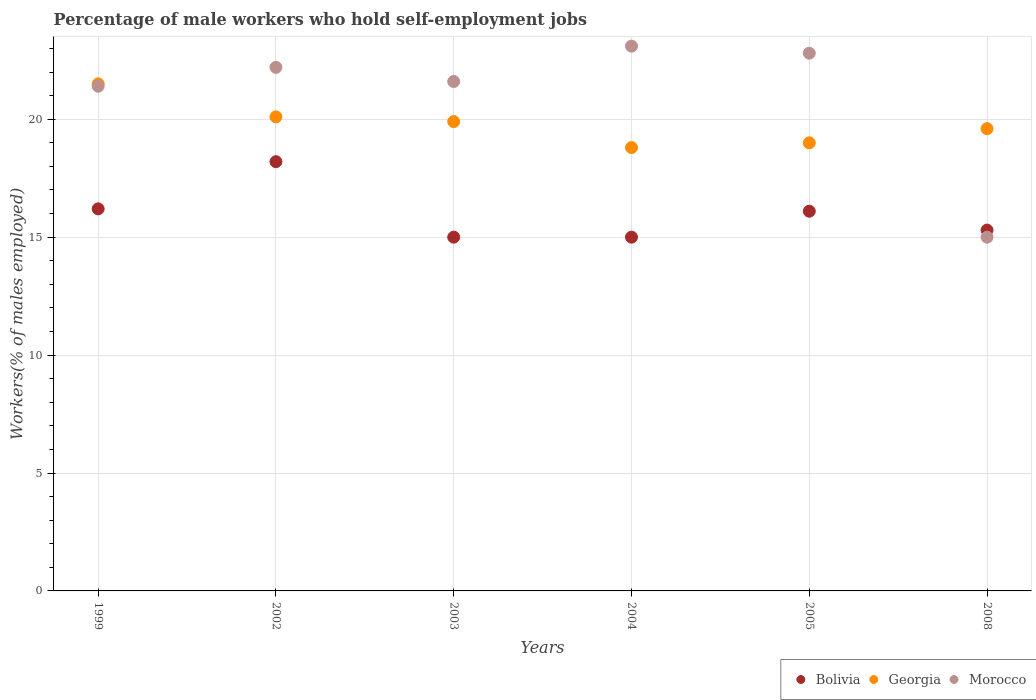What is the percentage of self-employed male workers in Bolivia in 2008?
Provide a succinct answer. 15.3. Across all years, what is the maximum percentage of self-employed male workers in Bolivia?
Your answer should be very brief. 18.2. Across all years, what is the minimum percentage of self-employed male workers in Georgia?
Your response must be concise. 18.8. In which year was the percentage of self-employed male workers in Bolivia maximum?
Your response must be concise. 2002. What is the total percentage of self-employed male workers in Bolivia in the graph?
Make the answer very short. 95.8. What is the difference between the percentage of self-employed male workers in Morocco in 2002 and that in 2003?
Your response must be concise. 0.6. What is the difference between the percentage of self-employed male workers in Georgia in 2004 and the percentage of self-employed male workers in Morocco in 2002?
Provide a succinct answer. -3.4. What is the average percentage of self-employed male workers in Bolivia per year?
Your answer should be compact. 15.97. In the year 2002, what is the difference between the percentage of self-employed male workers in Bolivia and percentage of self-employed male workers in Georgia?
Your answer should be very brief. -1.9. What is the ratio of the percentage of self-employed male workers in Bolivia in 2002 to that in 2008?
Ensure brevity in your answer.  1.19. Is the percentage of self-employed male workers in Morocco in 2002 less than that in 2005?
Ensure brevity in your answer.  Yes. Is the difference between the percentage of self-employed male workers in Bolivia in 2002 and 2008 greater than the difference between the percentage of self-employed male workers in Georgia in 2002 and 2008?
Offer a terse response. Yes. What is the difference between the highest and the lowest percentage of self-employed male workers in Morocco?
Offer a very short reply. 8.1. Is the sum of the percentage of self-employed male workers in Georgia in 1999 and 2002 greater than the maximum percentage of self-employed male workers in Bolivia across all years?
Your response must be concise. Yes. Is the percentage of self-employed male workers in Morocco strictly greater than the percentage of self-employed male workers in Bolivia over the years?
Offer a very short reply. No. How many dotlines are there?
Offer a very short reply. 3. What is the difference between two consecutive major ticks on the Y-axis?
Keep it short and to the point. 5. Does the graph contain any zero values?
Your response must be concise. No. How are the legend labels stacked?
Your answer should be very brief. Horizontal. What is the title of the graph?
Give a very brief answer. Percentage of male workers who hold self-employment jobs. Does "Georgia" appear as one of the legend labels in the graph?
Ensure brevity in your answer.  Yes. What is the label or title of the Y-axis?
Provide a short and direct response. Workers(% of males employed). What is the Workers(% of males employed) of Bolivia in 1999?
Provide a short and direct response. 16.2. What is the Workers(% of males employed) of Morocco in 1999?
Offer a very short reply. 21.4. What is the Workers(% of males employed) of Bolivia in 2002?
Offer a terse response. 18.2. What is the Workers(% of males employed) of Georgia in 2002?
Offer a terse response. 20.1. What is the Workers(% of males employed) in Morocco in 2002?
Give a very brief answer. 22.2. What is the Workers(% of males employed) of Bolivia in 2003?
Provide a short and direct response. 15. What is the Workers(% of males employed) in Georgia in 2003?
Make the answer very short. 19.9. What is the Workers(% of males employed) in Morocco in 2003?
Provide a succinct answer. 21.6. What is the Workers(% of males employed) of Bolivia in 2004?
Keep it short and to the point. 15. What is the Workers(% of males employed) of Georgia in 2004?
Your answer should be compact. 18.8. What is the Workers(% of males employed) in Morocco in 2004?
Give a very brief answer. 23.1. What is the Workers(% of males employed) of Bolivia in 2005?
Offer a terse response. 16.1. What is the Workers(% of males employed) of Georgia in 2005?
Your response must be concise. 19. What is the Workers(% of males employed) of Morocco in 2005?
Give a very brief answer. 22.8. What is the Workers(% of males employed) in Bolivia in 2008?
Your response must be concise. 15.3. What is the Workers(% of males employed) in Georgia in 2008?
Your answer should be compact. 19.6. What is the Workers(% of males employed) of Morocco in 2008?
Your answer should be compact. 15. Across all years, what is the maximum Workers(% of males employed) of Bolivia?
Provide a succinct answer. 18.2. Across all years, what is the maximum Workers(% of males employed) of Morocco?
Make the answer very short. 23.1. Across all years, what is the minimum Workers(% of males employed) of Georgia?
Your answer should be compact. 18.8. Across all years, what is the minimum Workers(% of males employed) in Morocco?
Offer a very short reply. 15. What is the total Workers(% of males employed) in Bolivia in the graph?
Give a very brief answer. 95.8. What is the total Workers(% of males employed) in Georgia in the graph?
Your answer should be compact. 118.9. What is the total Workers(% of males employed) of Morocco in the graph?
Your answer should be compact. 126.1. What is the difference between the Workers(% of males employed) of Georgia in 1999 and that in 2002?
Offer a very short reply. 1.4. What is the difference between the Workers(% of males employed) in Bolivia in 1999 and that in 2003?
Your answer should be compact. 1.2. What is the difference between the Workers(% of males employed) in Bolivia in 1999 and that in 2005?
Give a very brief answer. 0.1. What is the difference between the Workers(% of males employed) in Morocco in 1999 and that in 2005?
Your answer should be compact. -1.4. What is the difference between the Workers(% of males employed) in Bolivia in 1999 and that in 2008?
Give a very brief answer. 0.9. What is the difference between the Workers(% of males employed) of Morocco in 1999 and that in 2008?
Give a very brief answer. 6.4. What is the difference between the Workers(% of males employed) in Georgia in 2002 and that in 2004?
Your answer should be compact. 1.3. What is the difference between the Workers(% of males employed) in Morocco in 2002 and that in 2004?
Your answer should be compact. -0.9. What is the difference between the Workers(% of males employed) of Bolivia in 2002 and that in 2005?
Offer a terse response. 2.1. What is the difference between the Workers(% of males employed) of Georgia in 2002 and that in 2005?
Provide a short and direct response. 1.1. What is the difference between the Workers(% of males employed) in Georgia in 2002 and that in 2008?
Provide a succinct answer. 0.5. What is the difference between the Workers(% of males employed) in Bolivia in 2003 and that in 2004?
Offer a very short reply. 0. What is the difference between the Workers(% of males employed) of Georgia in 2003 and that in 2004?
Ensure brevity in your answer.  1.1. What is the difference between the Workers(% of males employed) of Morocco in 2003 and that in 2004?
Your answer should be compact. -1.5. What is the difference between the Workers(% of males employed) of Bolivia in 2003 and that in 2005?
Provide a succinct answer. -1.1. What is the difference between the Workers(% of males employed) in Georgia in 2003 and that in 2005?
Keep it short and to the point. 0.9. What is the difference between the Workers(% of males employed) in Morocco in 2003 and that in 2005?
Provide a succinct answer. -1.2. What is the difference between the Workers(% of males employed) in Bolivia in 2003 and that in 2008?
Your response must be concise. -0.3. What is the difference between the Workers(% of males employed) of Morocco in 2003 and that in 2008?
Offer a very short reply. 6.6. What is the difference between the Workers(% of males employed) of Bolivia in 2004 and that in 2005?
Make the answer very short. -1.1. What is the difference between the Workers(% of males employed) in Morocco in 2004 and that in 2005?
Offer a very short reply. 0.3. What is the difference between the Workers(% of males employed) in Georgia in 2004 and that in 2008?
Your answer should be very brief. -0.8. What is the difference between the Workers(% of males employed) in Bolivia in 1999 and the Workers(% of males employed) in Georgia in 2004?
Make the answer very short. -2.6. What is the difference between the Workers(% of males employed) in Georgia in 1999 and the Workers(% of males employed) in Morocco in 2004?
Keep it short and to the point. -1.6. What is the difference between the Workers(% of males employed) of Bolivia in 1999 and the Workers(% of males employed) of Georgia in 2005?
Offer a very short reply. -2.8. What is the difference between the Workers(% of males employed) in Bolivia in 1999 and the Workers(% of males employed) in Morocco in 2005?
Make the answer very short. -6.6. What is the difference between the Workers(% of males employed) of Georgia in 1999 and the Workers(% of males employed) of Morocco in 2005?
Provide a succinct answer. -1.3. What is the difference between the Workers(% of males employed) in Bolivia in 1999 and the Workers(% of males employed) in Georgia in 2008?
Your answer should be compact. -3.4. What is the difference between the Workers(% of males employed) in Bolivia in 1999 and the Workers(% of males employed) in Morocco in 2008?
Offer a very short reply. 1.2. What is the difference between the Workers(% of males employed) in Georgia in 1999 and the Workers(% of males employed) in Morocco in 2008?
Your answer should be compact. 6.5. What is the difference between the Workers(% of males employed) in Georgia in 2002 and the Workers(% of males employed) in Morocco in 2003?
Keep it short and to the point. -1.5. What is the difference between the Workers(% of males employed) in Bolivia in 2002 and the Workers(% of males employed) in Morocco in 2004?
Offer a very short reply. -4.9. What is the difference between the Workers(% of males employed) in Georgia in 2002 and the Workers(% of males employed) in Morocco in 2004?
Ensure brevity in your answer.  -3. What is the difference between the Workers(% of males employed) of Bolivia in 2002 and the Workers(% of males employed) of Georgia in 2005?
Offer a terse response. -0.8. What is the difference between the Workers(% of males employed) of Bolivia in 2002 and the Workers(% of males employed) of Morocco in 2005?
Keep it short and to the point. -4.6. What is the difference between the Workers(% of males employed) of Georgia in 2002 and the Workers(% of males employed) of Morocco in 2005?
Your response must be concise. -2.7. What is the difference between the Workers(% of males employed) in Bolivia in 2003 and the Workers(% of males employed) in Morocco in 2004?
Your answer should be compact. -8.1. What is the difference between the Workers(% of males employed) of Bolivia in 2003 and the Workers(% of males employed) of Georgia in 2005?
Provide a succinct answer. -4. What is the difference between the Workers(% of males employed) of Bolivia in 2003 and the Workers(% of males employed) of Georgia in 2008?
Ensure brevity in your answer.  -4.6. What is the difference between the Workers(% of males employed) of Bolivia in 2003 and the Workers(% of males employed) of Morocco in 2008?
Provide a succinct answer. 0. What is the difference between the Workers(% of males employed) in Bolivia in 2004 and the Workers(% of males employed) in Georgia in 2005?
Your answer should be very brief. -4. What is the difference between the Workers(% of males employed) of Bolivia in 2004 and the Workers(% of males employed) of Morocco in 2005?
Provide a succinct answer. -7.8. What is the difference between the Workers(% of males employed) in Bolivia in 2004 and the Workers(% of males employed) in Georgia in 2008?
Offer a very short reply. -4.6. What is the difference between the Workers(% of males employed) of Georgia in 2004 and the Workers(% of males employed) of Morocco in 2008?
Ensure brevity in your answer.  3.8. What is the difference between the Workers(% of males employed) of Georgia in 2005 and the Workers(% of males employed) of Morocco in 2008?
Give a very brief answer. 4. What is the average Workers(% of males employed) in Bolivia per year?
Ensure brevity in your answer.  15.97. What is the average Workers(% of males employed) in Georgia per year?
Give a very brief answer. 19.82. What is the average Workers(% of males employed) in Morocco per year?
Your answer should be very brief. 21.02. In the year 1999, what is the difference between the Workers(% of males employed) of Bolivia and Workers(% of males employed) of Georgia?
Offer a very short reply. -5.3. In the year 1999, what is the difference between the Workers(% of males employed) of Bolivia and Workers(% of males employed) of Morocco?
Ensure brevity in your answer.  -5.2. In the year 2003, what is the difference between the Workers(% of males employed) in Bolivia and Workers(% of males employed) in Morocco?
Offer a terse response. -6.6. In the year 2004, what is the difference between the Workers(% of males employed) of Bolivia and Workers(% of males employed) of Georgia?
Ensure brevity in your answer.  -3.8. In the year 2004, what is the difference between the Workers(% of males employed) of Bolivia and Workers(% of males employed) of Morocco?
Your answer should be compact. -8.1. In the year 2005, what is the difference between the Workers(% of males employed) in Bolivia and Workers(% of males employed) in Georgia?
Provide a short and direct response. -2.9. In the year 2005, what is the difference between the Workers(% of males employed) in Bolivia and Workers(% of males employed) in Morocco?
Your response must be concise. -6.7. In the year 2005, what is the difference between the Workers(% of males employed) in Georgia and Workers(% of males employed) in Morocco?
Offer a terse response. -3.8. In the year 2008, what is the difference between the Workers(% of males employed) in Georgia and Workers(% of males employed) in Morocco?
Give a very brief answer. 4.6. What is the ratio of the Workers(% of males employed) of Bolivia in 1999 to that in 2002?
Ensure brevity in your answer.  0.89. What is the ratio of the Workers(% of males employed) of Georgia in 1999 to that in 2002?
Provide a succinct answer. 1.07. What is the ratio of the Workers(% of males employed) of Bolivia in 1999 to that in 2003?
Provide a succinct answer. 1.08. What is the ratio of the Workers(% of males employed) of Georgia in 1999 to that in 2003?
Give a very brief answer. 1.08. What is the ratio of the Workers(% of males employed) of Morocco in 1999 to that in 2003?
Your answer should be very brief. 0.99. What is the ratio of the Workers(% of males employed) of Georgia in 1999 to that in 2004?
Your answer should be compact. 1.14. What is the ratio of the Workers(% of males employed) of Morocco in 1999 to that in 2004?
Give a very brief answer. 0.93. What is the ratio of the Workers(% of males employed) in Georgia in 1999 to that in 2005?
Your response must be concise. 1.13. What is the ratio of the Workers(% of males employed) of Morocco in 1999 to that in 2005?
Your response must be concise. 0.94. What is the ratio of the Workers(% of males employed) in Bolivia in 1999 to that in 2008?
Offer a terse response. 1.06. What is the ratio of the Workers(% of males employed) of Georgia in 1999 to that in 2008?
Your answer should be compact. 1.1. What is the ratio of the Workers(% of males employed) of Morocco in 1999 to that in 2008?
Your response must be concise. 1.43. What is the ratio of the Workers(% of males employed) in Bolivia in 2002 to that in 2003?
Offer a terse response. 1.21. What is the ratio of the Workers(% of males employed) in Georgia in 2002 to that in 2003?
Ensure brevity in your answer.  1.01. What is the ratio of the Workers(% of males employed) in Morocco in 2002 to that in 2003?
Ensure brevity in your answer.  1.03. What is the ratio of the Workers(% of males employed) of Bolivia in 2002 to that in 2004?
Your answer should be very brief. 1.21. What is the ratio of the Workers(% of males employed) of Georgia in 2002 to that in 2004?
Your answer should be very brief. 1.07. What is the ratio of the Workers(% of males employed) in Bolivia in 2002 to that in 2005?
Keep it short and to the point. 1.13. What is the ratio of the Workers(% of males employed) of Georgia in 2002 to that in 2005?
Provide a short and direct response. 1.06. What is the ratio of the Workers(% of males employed) in Morocco in 2002 to that in 2005?
Your answer should be very brief. 0.97. What is the ratio of the Workers(% of males employed) of Bolivia in 2002 to that in 2008?
Offer a very short reply. 1.19. What is the ratio of the Workers(% of males employed) of Georgia in 2002 to that in 2008?
Offer a terse response. 1.03. What is the ratio of the Workers(% of males employed) of Morocco in 2002 to that in 2008?
Keep it short and to the point. 1.48. What is the ratio of the Workers(% of males employed) of Bolivia in 2003 to that in 2004?
Your answer should be very brief. 1. What is the ratio of the Workers(% of males employed) of Georgia in 2003 to that in 2004?
Provide a short and direct response. 1.06. What is the ratio of the Workers(% of males employed) in Morocco in 2003 to that in 2004?
Keep it short and to the point. 0.94. What is the ratio of the Workers(% of males employed) in Bolivia in 2003 to that in 2005?
Offer a terse response. 0.93. What is the ratio of the Workers(% of males employed) in Georgia in 2003 to that in 2005?
Offer a very short reply. 1.05. What is the ratio of the Workers(% of males employed) in Morocco in 2003 to that in 2005?
Your response must be concise. 0.95. What is the ratio of the Workers(% of males employed) of Bolivia in 2003 to that in 2008?
Offer a terse response. 0.98. What is the ratio of the Workers(% of males employed) in Georgia in 2003 to that in 2008?
Your response must be concise. 1.02. What is the ratio of the Workers(% of males employed) of Morocco in 2003 to that in 2008?
Your answer should be very brief. 1.44. What is the ratio of the Workers(% of males employed) of Bolivia in 2004 to that in 2005?
Offer a terse response. 0.93. What is the ratio of the Workers(% of males employed) in Georgia in 2004 to that in 2005?
Your answer should be very brief. 0.99. What is the ratio of the Workers(% of males employed) in Morocco in 2004 to that in 2005?
Offer a terse response. 1.01. What is the ratio of the Workers(% of males employed) in Bolivia in 2004 to that in 2008?
Ensure brevity in your answer.  0.98. What is the ratio of the Workers(% of males employed) in Georgia in 2004 to that in 2008?
Provide a short and direct response. 0.96. What is the ratio of the Workers(% of males employed) in Morocco in 2004 to that in 2008?
Make the answer very short. 1.54. What is the ratio of the Workers(% of males employed) in Bolivia in 2005 to that in 2008?
Ensure brevity in your answer.  1.05. What is the ratio of the Workers(% of males employed) in Georgia in 2005 to that in 2008?
Offer a terse response. 0.97. What is the ratio of the Workers(% of males employed) in Morocco in 2005 to that in 2008?
Keep it short and to the point. 1.52. What is the difference between the highest and the second highest Workers(% of males employed) of Georgia?
Provide a succinct answer. 1.4. 